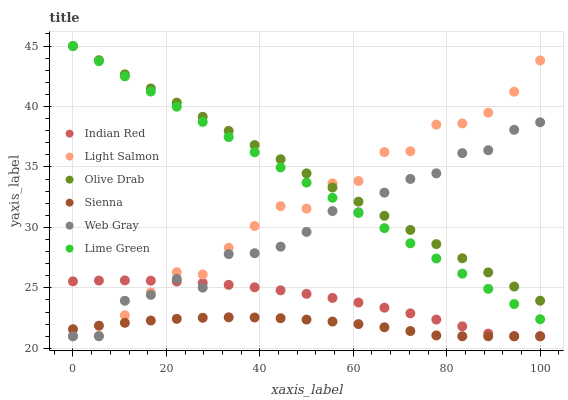Does Sienna have the minimum area under the curve?
Answer yes or no. Yes. Does Olive Drab have the maximum area under the curve?
Answer yes or no. Yes. Does Web Gray have the minimum area under the curve?
Answer yes or no. No. Does Web Gray have the maximum area under the curve?
Answer yes or no. No. Is Lime Green the smoothest?
Answer yes or no. Yes. Is Web Gray the roughest?
Answer yes or no. Yes. Is Sienna the smoothest?
Answer yes or no. No. Is Sienna the roughest?
Answer yes or no. No. Does Light Salmon have the lowest value?
Answer yes or no. Yes. Does Lime Green have the lowest value?
Answer yes or no. No. Does Olive Drab have the highest value?
Answer yes or no. Yes. Does Web Gray have the highest value?
Answer yes or no. No. Is Sienna less than Olive Drab?
Answer yes or no. Yes. Is Lime Green greater than Sienna?
Answer yes or no. Yes. Does Web Gray intersect Sienna?
Answer yes or no. Yes. Is Web Gray less than Sienna?
Answer yes or no. No. Is Web Gray greater than Sienna?
Answer yes or no. No. Does Sienna intersect Olive Drab?
Answer yes or no. No. 